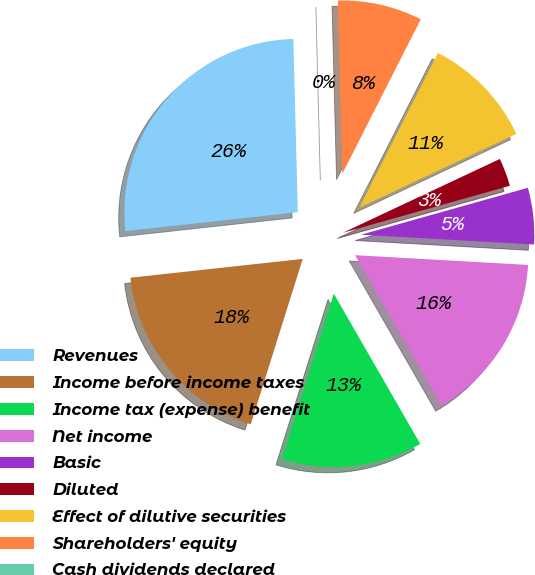Convert chart to OTSL. <chart><loc_0><loc_0><loc_500><loc_500><pie_chart><fcel>Revenues<fcel>Income before income taxes<fcel>Income tax (expense) benefit<fcel>Net income<fcel>Basic<fcel>Diluted<fcel>Effect of dilutive securities<fcel>Shareholders' equity<fcel>Cash dividends declared<nl><fcel>26.32%<fcel>18.42%<fcel>13.16%<fcel>15.79%<fcel>5.26%<fcel>2.63%<fcel>10.53%<fcel>7.89%<fcel>0.0%<nl></chart> 